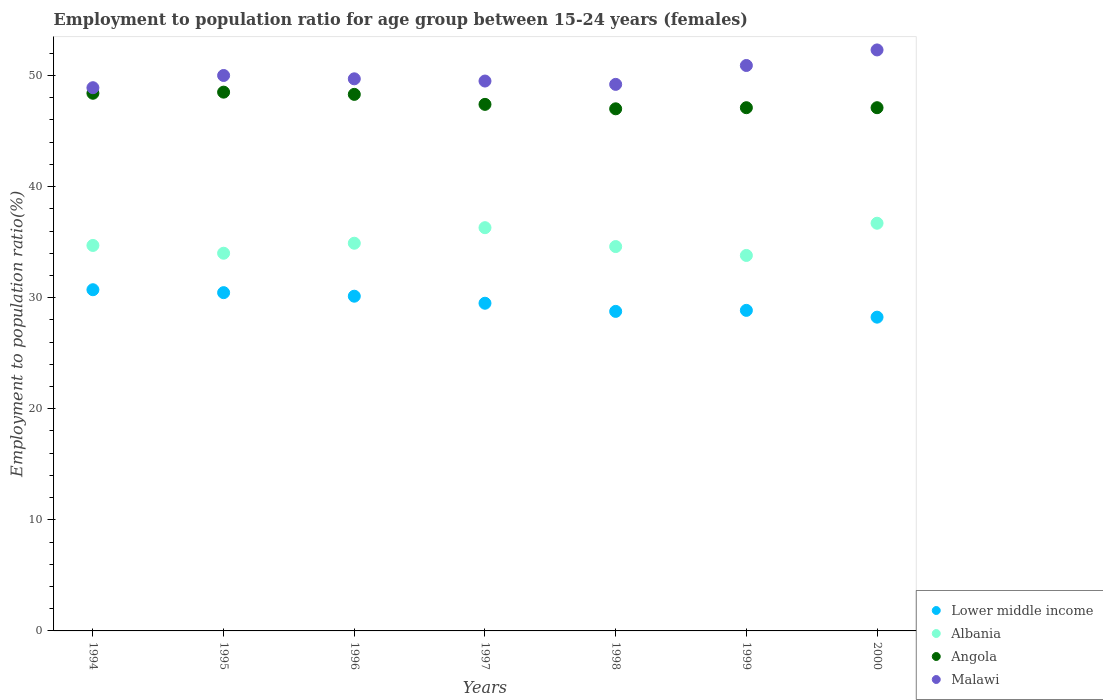Is the number of dotlines equal to the number of legend labels?
Keep it short and to the point. Yes. What is the employment to population ratio in Lower middle income in 1998?
Your answer should be compact. 28.76. Across all years, what is the maximum employment to population ratio in Malawi?
Your response must be concise. 52.3. Across all years, what is the minimum employment to population ratio in Albania?
Make the answer very short. 33.8. In which year was the employment to population ratio in Lower middle income maximum?
Your response must be concise. 1994. What is the total employment to population ratio in Angola in the graph?
Your answer should be very brief. 333.8. What is the difference between the employment to population ratio in Lower middle income in 1997 and that in 2000?
Give a very brief answer. 1.25. What is the difference between the employment to population ratio in Lower middle income in 1994 and the employment to population ratio in Angola in 1999?
Keep it short and to the point. -16.39. What is the average employment to population ratio in Lower middle income per year?
Your answer should be compact. 29.52. What is the ratio of the employment to population ratio in Malawi in 1994 to that in 1997?
Your answer should be compact. 0.99. Is the employment to population ratio in Angola in 1997 less than that in 1998?
Ensure brevity in your answer.  No. Is the difference between the employment to population ratio in Albania in 1995 and 1997 greater than the difference between the employment to population ratio in Angola in 1995 and 1997?
Offer a very short reply. No. What is the difference between the highest and the second highest employment to population ratio in Lower middle income?
Offer a very short reply. 0.26. In how many years, is the employment to population ratio in Malawi greater than the average employment to population ratio in Malawi taken over all years?
Your answer should be very brief. 2. What is the difference between two consecutive major ticks on the Y-axis?
Ensure brevity in your answer.  10. Does the graph contain any zero values?
Keep it short and to the point. No. Does the graph contain grids?
Offer a very short reply. No. Where does the legend appear in the graph?
Make the answer very short. Bottom right. How many legend labels are there?
Make the answer very short. 4. What is the title of the graph?
Give a very brief answer. Employment to population ratio for age group between 15-24 years (females). What is the label or title of the X-axis?
Your response must be concise. Years. What is the label or title of the Y-axis?
Give a very brief answer. Employment to population ratio(%). What is the Employment to population ratio(%) in Lower middle income in 1994?
Your response must be concise. 30.71. What is the Employment to population ratio(%) in Albania in 1994?
Give a very brief answer. 34.7. What is the Employment to population ratio(%) in Angola in 1994?
Your response must be concise. 48.4. What is the Employment to population ratio(%) of Malawi in 1994?
Provide a succinct answer. 48.9. What is the Employment to population ratio(%) in Lower middle income in 1995?
Offer a very short reply. 30.45. What is the Employment to population ratio(%) in Angola in 1995?
Keep it short and to the point. 48.5. What is the Employment to population ratio(%) in Lower middle income in 1996?
Keep it short and to the point. 30.13. What is the Employment to population ratio(%) in Albania in 1996?
Give a very brief answer. 34.9. What is the Employment to population ratio(%) of Angola in 1996?
Offer a terse response. 48.3. What is the Employment to population ratio(%) of Malawi in 1996?
Your response must be concise. 49.7. What is the Employment to population ratio(%) of Lower middle income in 1997?
Offer a terse response. 29.5. What is the Employment to population ratio(%) of Albania in 1997?
Keep it short and to the point. 36.3. What is the Employment to population ratio(%) in Angola in 1997?
Your answer should be very brief. 47.4. What is the Employment to population ratio(%) in Malawi in 1997?
Ensure brevity in your answer.  49.5. What is the Employment to population ratio(%) of Lower middle income in 1998?
Offer a very short reply. 28.76. What is the Employment to population ratio(%) of Albania in 1998?
Ensure brevity in your answer.  34.6. What is the Employment to population ratio(%) in Angola in 1998?
Offer a terse response. 47. What is the Employment to population ratio(%) in Malawi in 1998?
Your answer should be very brief. 49.2. What is the Employment to population ratio(%) of Lower middle income in 1999?
Your answer should be compact. 28.86. What is the Employment to population ratio(%) in Albania in 1999?
Provide a succinct answer. 33.8. What is the Employment to population ratio(%) of Angola in 1999?
Give a very brief answer. 47.1. What is the Employment to population ratio(%) in Malawi in 1999?
Your answer should be compact. 50.9. What is the Employment to population ratio(%) in Lower middle income in 2000?
Keep it short and to the point. 28.24. What is the Employment to population ratio(%) of Albania in 2000?
Make the answer very short. 36.7. What is the Employment to population ratio(%) of Angola in 2000?
Your answer should be compact. 47.1. What is the Employment to population ratio(%) of Malawi in 2000?
Make the answer very short. 52.3. Across all years, what is the maximum Employment to population ratio(%) of Lower middle income?
Your answer should be compact. 30.71. Across all years, what is the maximum Employment to population ratio(%) of Albania?
Offer a terse response. 36.7. Across all years, what is the maximum Employment to population ratio(%) of Angola?
Your answer should be very brief. 48.5. Across all years, what is the maximum Employment to population ratio(%) in Malawi?
Offer a very short reply. 52.3. Across all years, what is the minimum Employment to population ratio(%) of Lower middle income?
Give a very brief answer. 28.24. Across all years, what is the minimum Employment to population ratio(%) in Albania?
Offer a terse response. 33.8. Across all years, what is the minimum Employment to population ratio(%) in Malawi?
Provide a short and direct response. 48.9. What is the total Employment to population ratio(%) in Lower middle income in the graph?
Ensure brevity in your answer.  206.66. What is the total Employment to population ratio(%) in Albania in the graph?
Make the answer very short. 245. What is the total Employment to population ratio(%) in Angola in the graph?
Offer a terse response. 333.8. What is the total Employment to population ratio(%) of Malawi in the graph?
Keep it short and to the point. 350.5. What is the difference between the Employment to population ratio(%) in Lower middle income in 1994 and that in 1995?
Make the answer very short. 0.26. What is the difference between the Employment to population ratio(%) in Albania in 1994 and that in 1995?
Offer a very short reply. 0.7. What is the difference between the Employment to population ratio(%) of Angola in 1994 and that in 1995?
Your response must be concise. -0.1. What is the difference between the Employment to population ratio(%) in Lower middle income in 1994 and that in 1996?
Make the answer very short. 0.58. What is the difference between the Employment to population ratio(%) in Lower middle income in 1994 and that in 1997?
Your response must be concise. 1.22. What is the difference between the Employment to population ratio(%) in Lower middle income in 1994 and that in 1998?
Your answer should be compact. 1.95. What is the difference between the Employment to population ratio(%) in Malawi in 1994 and that in 1998?
Keep it short and to the point. -0.3. What is the difference between the Employment to population ratio(%) in Lower middle income in 1994 and that in 1999?
Ensure brevity in your answer.  1.86. What is the difference between the Employment to population ratio(%) of Angola in 1994 and that in 1999?
Offer a terse response. 1.3. What is the difference between the Employment to population ratio(%) in Lower middle income in 1994 and that in 2000?
Offer a very short reply. 2.47. What is the difference between the Employment to population ratio(%) in Albania in 1994 and that in 2000?
Ensure brevity in your answer.  -2. What is the difference between the Employment to population ratio(%) in Malawi in 1994 and that in 2000?
Ensure brevity in your answer.  -3.4. What is the difference between the Employment to population ratio(%) in Lower middle income in 1995 and that in 1996?
Offer a very short reply. 0.32. What is the difference between the Employment to population ratio(%) in Albania in 1995 and that in 1996?
Offer a very short reply. -0.9. What is the difference between the Employment to population ratio(%) in Angola in 1995 and that in 1996?
Give a very brief answer. 0.2. What is the difference between the Employment to population ratio(%) of Malawi in 1995 and that in 1996?
Offer a very short reply. 0.3. What is the difference between the Employment to population ratio(%) of Lower middle income in 1995 and that in 1997?
Provide a succinct answer. 0.95. What is the difference between the Employment to population ratio(%) of Lower middle income in 1995 and that in 1998?
Your response must be concise. 1.69. What is the difference between the Employment to population ratio(%) of Malawi in 1995 and that in 1998?
Provide a succinct answer. 0.8. What is the difference between the Employment to population ratio(%) in Lower middle income in 1995 and that in 1999?
Offer a terse response. 1.59. What is the difference between the Employment to population ratio(%) in Albania in 1995 and that in 1999?
Provide a short and direct response. 0.2. What is the difference between the Employment to population ratio(%) in Lower middle income in 1995 and that in 2000?
Provide a short and direct response. 2.21. What is the difference between the Employment to population ratio(%) in Lower middle income in 1996 and that in 1997?
Your answer should be compact. 0.63. What is the difference between the Employment to population ratio(%) in Malawi in 1996 and that in 1997?
Make the answer very short. 0.2. What is the difference between the Employment to population ratio(%) in Lower middle income in 1996 and that in 1998?
Your response must be concise. 1.37. What is the difference between the Employment to population ratio(%) in Albania in 1996 and that in 1998?
Offer a very short reply. 0.3. What is the difference between the Employment to population ratio(%) in Lower middle income in 1996 and that in 1999?
Give a very brief answer. 1.27. What is the difference between the Employment to population ratio(%) in Angola in 1996 and that in 1999?
Give a very brief answer. 1.2. What is the difference between the Employment to population ratio(%) in Malawi in 1996 and that in 1999?
Provide a short and direct response. -1.2. What is the difference between the Employment to population ratio(%) in Lower middle income in 1996 and that in 2000?
Give a very brief answer. 1.89. What is the difference between the Employment to population ratio(%) in Angola in 1996 and that in 2000?
Offer a terse response. 1.2. What is the difference between the Employment to population ratio(%) in Lower middle income in 1997 and that in 1998?
Your answer should be compact. 0.73. What is the difference between the Employment to population ratio(%) of Albania in 1997 and that in 1998?
Your answer should be very brief. 1.7. What is the difference between the Employment to population ratio(%) in Malawi in 1997 and that in 1998?
Ensure brevity in your answer.  0.3. What is the difference between the Employment to population ratio(%) in Lower middle income in 1997 and that in 1999?
Give a very brief answer. 0.64. What is the difference between the Employment to population ratio(%) of Albania in 1997 and that in 1999?
Ensure brevity in your answer.  2.5. What is the difference between the Employment to population ratio(%) of Malawi in 1997 and that in 1999?
Your response must be concise. -1.4. What is the difference between the Employment to population ratio(%) of Lower middle income in 1997 and that in 2000?
Make the answer very short. 1.25. What is the difference between the Employment to population ratio(%) of Albania in 1997 and that in 2000?
Give a very brief answer. -0.4. What is the difference between the Employment to population ratio(%) in Lower middle income in 1998 and that in 1999?
Provide a short and direct response. -0.09. What is the difference between the Employment to population ratio(%) of Angola in 1998 and that in 1999?
Offer a terse response. -0.1. What is the difference between the Employment to population ratio(%) of Lower middle income in 1998 and that in 2000?
Provide a short and direct response. 0.52. What is the difference between the Employment to population ratio(%) of Albania in 1998 and that in 2000?
Ensure brevity in your answer.  -2.1. What is the difference between the Employment to population ratio(%) of Angola in 1998 and that in 2000?
Provide a succinct answer. -0.1. What is the difference between the Employment to population ratio(%) of Malawi in 1998 and that in 2000?
Offer a very short reply. -3.1. What is the difference between the Employment to population ratio(%) in Lower middle income in 1999 and that in 2000?
Give a very brief answer. 0.61. What is the difference between the Employment to population ratio(%) of Albania in 1999 and that in 2000?
Offer a terse response. -2.9. What is the difference between the Employment to population ratio(%) in Angola in 1999 and that in 2000?
Your answer should be very brief. 0. What is the difference between the Employment to population ratio(%) in Malawi in 1999 and that in 2000?
Your response must be concise. -1.4. What is the difference between the Employment to population ratio(%) in Lower middle income in 1994 and the Employment to population ratio(%) in Albania in 1995?
Offer a terse response. -3.29. What is the difference between the Employment to population ratio(%) in Lower middle income in 1994 and the Employment to population ratio(%) in Angola in 1995?
Ensure brevity in your answer.  -17.79. What is the difference between the Employment to population ratio(%) of Lower middle income in 1994 and the Employment to population ratio(%) of Malawi in 1995?
Give a very brief answer. -19.29. What is the difference between the Employment to population ratio(%) in Albania in 1994 and the Employment to population ratio(%) in Malawi in 1995?
Give a very brief answer. -15.3. What is the difference between the Employment to population ratio(%) in Angola in 1994 and the Employment to population ratio(%) in Malawi in 1995?
Offer a very short reply. -1.6. What is the difference between the Employment to population ratio(%) in Lower middle income in 1994 and the Employment to population ratio(%) in Albania in 1996?
Provide a short and direct response. -4.19. What is the difference between the Employment to population ratio(%) in Lower middle income in 1994 and the Employment to population ratio(%) in Angola in 1996?
Make the answer very short. -17.59. What is the difference between the Employment to population ratio(%) in Lower middle income in 1994 and the Employment to population ratio(%) in Malawi in 1996?
Keep it short and to the point. -18.99. What is the difference between the Employment to population ratio(%) in Albania in 1994 and the Employment to population ratio(%) in Malawi in 1996?
Your answer should be very brief. -15. What is the difference between the Employment to population ratio(%) in Angola in 1994 and the Employment to population ratio(%) in Malawi in 1996?
Your response must be concise. -1.3. What is the difference between the Employment to population ratio(%) in Lower middle income in 1994 and the Employment to population ratio(%) in Albania in 1997?
Offer a very short reply. -5.59. What is the difference between the Employment to population ratio(%) of Lower middle income in 1994 and the Employment to population ratio(%) of Angola in 1997?
Keep it short and to the point. -16.69. What is the difference between the Employment to population ratio(%) of Lower middle income in 1994 and the Employment to population ratio(%) of Malawi in 1997?
Give a very brief answer. -18.79. What is the difference between the Employment to population ratio(%) in Albania in 1994 and the Employment to population ratio(%) in Angola in 1997?
Make the answer very short. -12.7. What is the difference between the Employment to population ratio(%) of Albania in 1994 and the Employment to population ratio(%) of Malawi in 1997?
Provide a succinct answer. -14.8. What is the difference between the Employment to population ratio(%) in Lower middle income in 1994 and the Employment to population ratio(%) in Albania in 1998?
Your answer should be very brief. -3.89. What is the difference between the Employment to population ratio(%) of Lower middle income in 1994 and the Employment to population ratio(%) of Angola in 1998?
Your answer should be compact. -16.29. What is the difference between the Employment to population ratio(%) in Lower middle income in 1994 and the Employment to population ratio(%) in Malawi in 1998?
Your answer should be very brief. -18.49. What is the difference between the Employment to population ratio(%) of Albania in 1994 and the Employment to population ratio(%) of Malawi in 1998?
Give a very brief answer. -14.5. What is the difference between the Employment to population ratio(%) of Lower middle income in 1994 and the Employment to population ratio(%) of Albania in 1999?
Your response must be concise. -3.09. What is the difference between the Employment to population ratio(%) of Lower middle income in 1994 and the Employment to population ratio(%) of Angola in 1999?
Provide a short and direct response. -16.39. What is the difference between the Employment to population ratio(%) in Lower middle income in 1994 and the Employment to population ratio(%) in Malawi in 1999?
Your answer should be very brief. -20.19. What is the difference between the Employment to population ratio(%) of Albania in 1994 and the Employment to population ratio(%) of Malawi in 1999?
Your answer should be very brief. -16.2. What is the difference between the Employment to population ratio(%) of Lower middle income in 1994 and the Employment to population ratio(%) of Albania in 2000?
Give a very brief answer. -5.99. What is the difference between the Employment to population ratio(%) of Lower middle income in 1994 and the Employment to population ratio(%) of Angola in 2000?
Your answer should be very brief. -16.39. What is the difference between the Employment to population ratio(%) in Lower middle income in 1994 and the Employment to population ratio(%) in Malawi in 2000?
Offer a terse response. -21.59. What is the difference between the Employment to population ratio(%) of Albania in 1994 and the Employment to population ratio(%) of Malawi in 2000?
Make the answer very short. -17.6. What is the difference between the Employment to population ratio(%) in Lower middle income in 1995 and the Employment to population ratio(%) in Albania in 1996?
Make the answer very short. -4.45. What is the difference between the Employment to population ratio(%) of Lower middle income in 1995 and the Employment to population ratio(%) of Angola in 1996?
Offer a very short reply. -17.85. What is the difference between the Employment to population ratio(%) of Lower middle income in 1995 and the Employment to population ratio(%) of Malawi in 1996?
Your answer should be compact. -19.25. What is the difference between the Employment to population ratio(%) of Albania in 1995 and the Employment to population ratio(%) of Angola in 1996?
Offer a very short reply. -14.3. What is the difference between the Employment to population ratio(%) of Albania in 1995 and the Employment to population ratio(%) of Malawi in 1996?
Make the answer very short. -15.7. What is the difference between the Employment to population ratio(%) in Lower middle income in 1995 and the Employment to population ratio(%) in Albania in 1997?
Your response must be concise. -5.85. What is the difference between the Employment to population ratio(%) in Lower middle income in 1995 and the Employment to population ratio(%) in Angola in 1997?
Provide a succinct answer. -16.95. What is the difference between the Employment to population ratio(%) of Lower middle income in 1995 and the Employment to population ratio(%) of Malawi in 1997?
Provide a succinct answer. -19.05. What is the difference between the Employment to population ratio(%) in Albania in 1995 and the Employment to population ratio(%) in Angola in 1997?
Make the answer very short. -13.4. What is the difference between the Employment to population ratio(%) in Albania in 1995 and the Employment to population ratio(%) in Malawi in 1997?
Offer a very short reply. -15.5. What is the difference between the Employment to population ratio(%) in Angola in 1995 and the Employment to population ratio(%) in Malawi in 1997?
Make the answer very short. -1. What is the difference between the Employment to population ratio(%) of Lower middle income in 1995 and the Employment to population ratio(%) of Albania in 1998?
Provide a short and direct response. -4.15. What is the difference between the Employment to population ratio(%) of Lower middle income in 1995 and the Employment to population ratio(%) of Angola in 1998?
Offer a very short reply. -16.55. What is the difference between the Employment to population ratio(%) in Lower middle income in 1995 and the Employment to population ratio(%) in Malawi in 1998?
Make the answer very short. -18.75. What is the difference between the Employment to population ratio(%) in Albania in 1995 and the Employment to population ratio(%) in Angola in 1998?
Your answer should be compact. -13. What is the difference between the Employment to population ratio(%) of Albania in 1995 and the Employment to population ratio(%) of Malawi in 1998?
Your response must be concise. -15.2. What is the difference between the Employment to population ratio(%) in Angola in 1995 and the Employment to population ratio(%) in Malawi in 1998?
Your answer should be compact. -0.7. What is the difference between the Employment to population ratio(%) of Lower middle income in 1995 and the Employment to population ratio(%) of Albania in 1999?
Your answer should be very brief. -3.35. What is the difference between the Employment to population ratio(%) in Lower middle income in 1995 and the Employment to population ratio(%) in Angola in 1999?
Make the answer very short. -16.65. What is the difference between the Employment to population ratio(%) in Lower middle income in 1995 and the Employment to population ratio(%) in Malawi in 1999?
Your answer should be compact. -20.45. What is the difference between the Employment to population ratio(%) in Albania in 1995 and the Employment to population ratio(%) in Malawi in 1999?
Ensure brevity in your answer.  -16.9. What is the difference between the Employment to population ratio(%) of Lower middle income in 1995 and the Employment to population ratio(%) of Albania in 2000?
Keep it short and to the point. -6.25. What is the difference between the Employment to population ratio(%) in Lower middle income in 1995 and the Employment to population ratio(%) in Angola in 2000?
Give a very brief answer. -16.65. What is the difference between the Employment to population ratio(%) in Lower middle income in 1995 and the Employment to population ratio(%) in Malawi in 2000?
Keep it short and to the point. -21.85. What is the difference between the Employment to population ratio(%) in Albania in 1995 and the Employment to population ratio(%) in Malawi in 2000?
Your answer should be very brief. -18.3. What is the difference between the Employment to population ratio(%) of Angola in 1995 and the Employment to population ratio(%) of Malawi in 2000?
Your answer should be compact. -3.8. What is the difference between the Employment to population ratio(%) of Lower middle income in 1996 and the Employment to population ratio(%) of Albania in 1997?
Offer a terse response. -6.17. What is the difference between the Employment to population ratio(%) in Lower middle income in 1996 and the Employment to population ratio(%) in Angola in 1997?
Provide a succinct answer. -17.27. What is the difference between the Employment to population ratio(%) in Lower middle income in 1996 and the Employment to population ratio(%) in Malawi in 1997?
Give a very brief answer. -19.37. What is the difference between the Employment to population ratio(%) of Albania in 1996 and the Employment to population ratio(%) of Malawi in 1997?
Provide a succinct answer. -14.6. What is the difference between the Employment to population ratio(%) of Lower middle income in 1996 and the Employment to population ratio(%) of Albania in 1998?
Keep it short and to the point. -4.47. What is the difference between the Employment to population ratio(%) of Lower middle income in 1996 and the Employment to population ratio(%) of Angola in 1998?
Your answer should be very brief. -16.87. What is the difference between the Employment to population ratio(%) in Lower middle income in 1996 and the Employment to population ratio(%) in Malawi in 1998?
Provide a short and direct response. -19.07. What is the difference between the Employment to population ratio(%) of Albania in 1996 and the Employment to population ratio(%) of Malawi in 1998?
Your answer should be very brief. -14.3. What is the difference between the Employment to population ratio(%) in Lower middle income in 1996 and the Employment to population ratio(%) in Albania in 1999?
Your answer should be very brief. -3.67. What is the difference between the Employment to population ratio(%) of Lower middle income in 1996 and the Employment to population ratio(%) of Angola in 1999?
Make the answer very short. -16.97. What is the difference between the Employment to population ratio(%) in Lower middle income in 1996 and the Employment to population ratio(%) in Malawi in 1999?
Give a very brief answer. -20.77. What is the difference between the Employment to population ratio(%) of Albania in 1996 and the Employment to population ratio(%) of Angola in 1999?
Provide a succinct answer. -12.2. What is the difference between the Employment to population ratio(%) in Angola in 1996 and the Employment to population ratio(%) in Malawi in 1999?
Your answer should be very brief. -2.6. What is the difference between the Employment to population ratio(%) of Lower middle income in 1996 and the Employment to population ratio(%) of Albania in 2000?
Provide a short and direct response. -6.57. What is the difference between the Employment to population ratio(%) of Lower middle income in 1996 and the Employment to population ratio(%) of Angola in 2000?
Provide a succinct answer. -16.97. What is the difference between the Employment to population ratio(%) of Lower middle income in 1996 and the Employment to population ratio(%) of Malawi in 2000?
Give a very brief answer. -22.17. What is the difference between the Employment to population ratio(%) in Albania in 1996 and the Employment to population ratio(%) in Malawi in 2000?
Your answer should be compact. -17.4. What is the difference between the Employment to population ratio(%) in Angola in 1996 and the Employment to population ratio(%) in Malawi in 2000?
Offer a very short reply. -4. What is the difference between the Employment to population ratio(%) in Lower middle income in 1997 and the Employment to population ratio(%) in Albania in 1998?
Keep it short and to the point. -5.1. What is the difference between the Employment to population ratio(%) of Lower middle income in 1997 and the Employment to population ratio(%) of Angola in 1998?
Provide a succinct answer. -17.5. What is the difference between the Employment to population ratio(%) of Lower middle income in 1997 and the Employment to population ratio(%) of Malawi in 1998?
Provide a succinct answer. -19.7. What is the difference between the Employment to population ratio(%) in Albania in 1997 and the Employment to population ratio(%) in Angola in 1998?
Give a very brief answer. -10.7. What is the difference between the Employment to population ratio(%) of Albania in 1997 and the Employment to population ratio(%) of Malawi in 1998?
Your answer should be compact. -12.9. What is the difference between the Employment to population ratio(%) in Angola in 1997 and the Employment to population ratio(%) in Malawi in 1998?
Offer a terse response. -1.8. What is the difference between the Employment to population ratio(%) in Lower middle income in 1997 and the Employment to population ratio(%) in Albania in 1999?
Your response must be concise. -4.3. What is the difference between the Employment to population ratio(%) of Lower middle income in 1997 and the Employment to population ratio(%) of Angola in 1999?
Provide a short and direct response. -17.6. What is the difference between the Employment to population ratio(%) in Lower middle income in 1997 and the Employment to population ratio(%) in Malawi in 1999?
Keep it short and to the point. -21.4. What is the difference between the Employment to population ratio(%) of Albania in 1997 and the Employment to population ratio(%) of Malawi in 1999?
Offer a very short reply. -14.6. What is the difference between the Employment to population ratio(%) in Angola in 1997 and the Employment to population ratio(%) in Malawi in 1999?
Your response must be concise. -3.5. What is the difference between the Employment to population ratio(%) in Lower middle income in 1997 and the Employment to population ratio(%) in Albania in 2000?
Give a very brief answer. -7.2. What is the difference between the Employment to population ratio(%) of Lower middle income in 1997 and the Employment to population ratio(%) of Angola in 2000?
Keep it short and to the point. -17.6. What is the difference between the Employment to population ratio(%) in Lower middle income in 1997 and the Employment to population ratio(%) in Malawi in 2000?
Make the answer very short. -22.8. What is the difference between the Employment to population ratio(%) of Albania in 1997 and the Employment to population ratio(%) of Angola in 2000?
Provide a short and direct response. -10.8. What is the difference between the Employment to population ratio(%) in Lower middle income in 1998 and the Employment to population ratio(%) in Albania in 1999?
Provide a short and direct response. -5.04. What is the difference between the Employment to population ratio(%) of Lower middle income in 1998 and the Employment to population ratio(%) of Angola in 1999?
Keep it short and to the point. -18.34. What is the difference between the Employment to population ratio(%) of Lower middle income in 1998 and the Employment to population ratio(%) of Malawi in 1999?
Your answer should be compact. -22.14. What is the difference between the Employment to population ratio(%) in Albania in 1998 and the Employment to population ratio(%) in Malawi in 1999?
Give a very brief answer. -16.3. What is the difference between the Employment to population ratio(%) in Lower middle income in 1998 and the Employment to population ratio(%) in Albania in 2000?
Offer a terse response. -7.94. What is the difference between the Employment to population ratio(%) of Lower middle income in 1998 and the Employment to population ratio(%) of Angola in 2000?
Your answer should be compact. -18.34. What is the difference between the Employment to population ratio(%) in Lower middle income in 1998 and the Employment to population ratio(%) in Malawi in 2000?
Ensure brevity in your answer.  -23.54. What is the difference between the Employment to population ratio(%) of Albania in 1998 and the Employment to population ratio(%) of Malawi in 2000?
Your answer should be very brief. -17.7. What is the difference between the Employment to population ratio(%) in Angola in 1998 and the Employment to population ratio(%) in Malawi in 2000?
Offer a terse response. -5.3. What is the difference between the Employment to population ratio(%) in Lower middle income in 1999 and the Employment to population ratio(%) in Albania in 2000?
Provide a succinct answer. -7.84. What is the difference between the Employment to population ratio(%) in Lower middle income in 1999 and the Employment to population ratio(%) in Angola in 2000?
Offer a very short reply. -18.24. What is the difference between the Employment to population ratio(%) in Lower middle income in 1999 and the Employment to population ratio(%) in Malawi in 2000?
Provide a succinct answer. -23.44. What is the difference between the Employment to population ratio(%) of Albania in 1999 and the Employment to population ratio(%) of Angola in 2000?
Give a very brief answer. -13.3. What is the difference between the Employment to population ratio(%) in Albania in 1999 and the Employment to population ratio(%) in Malawi in 2000?
Give a very brief answer. -18.5. What is the difference between the Employment to population ratio(%) of Angola in 1999 and the Employment to population ratio(%) of Malawi in 2000?
Your response must be concise. -5.2. What is the average Employment to population ratio(%) of Lower middle income per year?
Offer a terse response. 29.52. What is the average Employment to population ratio(%) in Albania per year?
Give a very brief answer. 35. What is the average Employment to population ratio(%) of Angola per year?
Ensure brevity in your answer.  47.69. What is the average Employment to population ratio(%) of Malawi per year?
Your response must be concise. 50.07. In the year 1994, what is the difference between the Employment to population ratio(%) of Lower middle income and Employment to population ratio(%) of Albania?
Offer a very short reply. -3.99. In the year 1994, what is the difference between the Employment to population ratio(%) in Lower middle income and Employment to population ratio(%) in Angola?
Provide a short and direct response. -17.69. In the year 1994, what is the difference between the Employment to population ratio(%) of Lower middle income and Employment to population ratio(%) of Malawi?
Keep it short and to the point. -18.19. In the year 1994, what is the difference between the Employment to population ratio(%) of Albania and Employment to population ratio(%) of Angola?
Your answer should be very brief. -13.7. In the year 1994, what is the difference between the Employment to population ratio(%) of Angola and Employment to population ratio(%) of Malawi?
Keep it short and to the point. -0.5. In the year 1995, what is the difference between the Employment to population ratio(%) in Lower middle income and Employment to population ratio(%) in Albania?
Ensure brevity in your answer.  -3.55. In the year 1995, what is the difference between the Employment to population ratio(%) of Lower middle income and Employment to population ratio(%) of Angola?
Give a very brief answer. -18.05. In the year 1995, what is the difference between the Employment to population ratio(%) of Lower middle income and Employment to population ratio(%) of Malawi?
Give a very brief answer. -19.55. In the year 1996, what is the difference between the Employment to population ratio(%) of Lower middle income and Employment to population ratio(%) of Albania?
Provide a short and direct response. -4.77. In the year 1996, what is the difference between the Employment to population ratio(%) of Lower middle income and Employment to population ratio(%) of Angola?
Keep it short and to the point. -18.17. In the year 1996, what is the difference between the Employment to population ratio(%) in Lower middle income and Employment to population ratio(%) in Malawi?
Provide a succinct answer. -19.57. In the year 1996, what is the difference between the Employment to population ratio(%) in Albania and Employment to population ratio(%) in Malawi?
Make the answer very short. -14.8. In the year 1996, what is the difference between the Employment to population ratio(%) in Angola and Employment to population ratio(%) in Malawi?
Keep it short and to the point. -1.4. In the year 1997, what is the difference between the Employment to population ratio(%) in Lower middle income and Employment to population ratio(%) in Albania?
Offer a terse response. -6.8. In the year 1997, what is the difference between the Employment to population ratio(%) of Lower middle income and Employment to population ratio(%) of Angola?
Give a very brief answer. -17.9. In the year 1997, what is the difference between the Employment to population ratio(%) in Lower middle income and Employment to population ratio(%) in Malawi?
Keep it short and to the point. -20. In the year 1998, what is the difference between the Employment to population ratio(%) of Lower middle income and Employment to population ratio(%) of Albania?
Ensure brevity in your answer.  -5.84. In the year 1998, what is the difference between the Employment to population ratio(%) in Lower middle income and Employment to population ratio(%) in Angola?
Provide a succinct answer. -18.24. In the year 1998, what is the difference between the Employment to population ratio(%) of Lower middle income and Employment to population ratio(%) of Malawi?
Provide a succinct answer. -20.44. In the year 1998, what is the difference between the Employment to population ratio(%) in Albania and Employment to population ratio(%) in Malawi?
Offer a very short reply. -14.6. In the year 1998, what is the difference between the Employment to population ratio(%) in Angola and Employment to population ratio(%) in Malawi?
Provide a succinct answer. -2.2. In the year 1999, what is the difference between the Employment to population ratio(%) of Lower middle income and Employment to population ratio(%) of Albania?
Your answer should be compact. -4.94. In the year 1999, what is the difference between the Employment to population ratio(%) of Lower middle income and Employment to population ratio(%) of Angola?
Make the answer very short. -18.24. In the year 1999, what is the difference between the Employment to population ratio(%) in Lower middle income and Employment to population ratio(%) in Malawi?
Offer a very short reply. -22.04. In the year 1999, what is the difference between the Employment to population ratio(%) in Albania and Employment to population ratio(%) in Angola?
Give a very brief answer. -13.3. In the year 1999, what is the difference between the Employment to population ratio(%) of Albania and Employment to population ratio(%) of Malawi?
Provide a short and direct response. -17.1. In the year 1999, what is the difference between the Employment to population ratio(%) in Angola and Employment to population ratio(%) in Malawi?
Your answer should be compact. -3.8. In the year 2000, what is the difference between the Employment to population ratio(%) of Lower middle income and Employment to population ratio(%) of Albania?
Keep it short and to the point. -8.46. In the year 2000, what is the difference between the Employment to population ratio(%) of Lower middle income and Employment to population ratio(%) of Angola?
Your answer should be compact. -18.86. In the year 2000, what is the difference between the Employment to population ratio(%) in Lower middle income and Employment to population ratio(%) in Malawi?
Your response must be concise. -24.06. In the year 2000, what is the difference between the Employment to population ratio(%) of Albania and Employment to population ratio(%) of Malawi?
Your answer should be very brief. -15.6. What is the ratio of the Employment to population ratio(%) in Lower middle income in 1994 to that in 1995?
Your answer should be compact. 1.01. What is the ratio of the Employment to population ratio(%) of Albania in 1994 to that in 1995?
Provide a short and direct response. 1.02. What is the ratio of the Employment to population ratio(%) in Malawi in 1994 to that in 1995?
Ensure brevity in your answer.  0.98. What is the ratio of the Employment to population ratio(%) in Lower middle income in 1994 to that in 1996?
Your response must be concise. 1.02. What is the ratio of the Employment to population ratio(%) in Angola in 1994 to that in 1996?
Make the answer very short. 1. What is the ratio of the Employment to population ratio(%) of Malawi in 1994 to that in 1996?
Offer a very short reply. 0.98. What is the ratio of the Employment to population ratio(%) in Lower middle income in 1994 to that in 1997?
Provide a succinct answer. 1.04. What is the ratio of the Employment to population ratio(%) of Albania in 1994 to that in 1997?
Offer a terse response. 0.96. What is the ratio of the Employment to population ratio(%) of Angola in 1994 to that in 1997?
Keep it short and to the point. 1.02. What is the ratio of the Employment to population ratio(%) in Malawi in 1994 to that in 1997?
Offer a very short reply. 0.99. What is the ratio of the Employment to population ratio(%) of Lower middle income in 1994 to that in 1998?
Your answer should be very brief. 1.07. What is the ratio of the Employment to population ratio(%) in Albania in 1994 to that in 1998?
Provide a short and direct response. 1. What is the ratio of the Employment to population ratio(%) of Angola in 1994 to that in 1998?
Provide a succinct answer. 1.03. What is the ratio of the Employment to population ratio(%) in Malawi in 1994 to that in 1998?
Provide a short and direct response. 0.99. What is the ratio of the Employment to population ratio(%) of Lower middle income in 1994 to that in 1999?
Offer a very short reply. 1.06. What is the ratio of the Employment to population ratio(%) in Albania in 1994 to that in 1999?
Make the answer very short. 1.03. What is the ratio of the Employment to population ratio(%) in Angola in 1994 to that in 1999?
Provide a short and direct response. 1.03. What is the ratio of the Employment to population ratio(%) in Malawi in 1994 to that in 1999?
Provide a short and direct response. 0.96. What is the ratio of the Employment to population ratio(%) of Lower middle income in 1994 to that in 2000?
Your answer should be compact. 1.09. What is the ratio of the Employment to population ratio(%) of Albania in 1994 to that in 2000?
Provide a succinct answer. 0.95. What is the ratio of the Employment to population ratio(%) in Angola in 1994 to that in 2000?
Offer a very short reply. 1.03. What is the ratio of the Employment to population ratio(%) of Malawi in 1994 to that in 2000?
Your answer should be very brief. 0.94. What is the ratio of the Employment to population ratio(%) in Lower middle income in 1995 to that in 1996?
Your answer should be compact. 1.01. What is the ratio of the Employment to population ratio(%) in Albania in 1995 to that in 1996?
Offer a very short reply. 0.97. What is the ratio of the Employment to population ratio(%) in Angola in 1995 to that in 1996?
Ensure brevity in your answer.  1. What is the ratio of the Employment to population ratio(%) in Lower middle income in 1995 to that in 1997?
Provide a short and direct response. 1.03. What is the ratio of the Employment to population ratio(%) in Albania in 1995 to that in 1997?
Provide a short and direct response. 0.94. What is the ratio of the Employment to population ratio(%) in Angola in 1995 to that in 1997?
Give a very brief answer. 1.02. What is the ratio of the Employment to population ratio(%) in Malawi in 1995 to that in 1997?
Keep it short and to the point. 1.01. What is the ratio of the Employment to population ratio(%) in Lower middle income in 1995 to that in 1998?
Your answer should be compact. 1.06. What is the ratio of the Employment to population ratio(%) of Albania in 1995 to that in 1998?
Provide a succinct answer. 0.98. What is the ratio of the Employment to population ratio(%) in Angola in 1995 to that in 1998?
Your response must be concise. 1.03. What is the ratio of the Employment to population ratio(%) in Malawi in 1995 to that in 1998?
Offer a terse response. 1.02. What is the ratio of the Employment to population ratio(%) in Lower middle income in 1995 to that in 1999?
Provide a short and direct response. 1.06. What is the ratio of the Employment to population ratio(%) in Albania in 1995 to that in 1999?
Provide a short and direct response. 1.01. What is the ratio of the Employment to population ratio(%) in Angola in 1995 to that in 1999?
Offer a terse response. 1.03. What is the ratio of the Employment to population ratio(%) of Malawi in 1995 to that in 1999?
Provide a short and direct response. 0.98. What is the ratio of the Employment to population ratio(%) of Lower middle income in 1995 to that in 2000?
Keep it short and to the point. 1.08. What is the ratio of the Employment to population ratio(%) in Albania in 1995 to that in 2000?
Provide a succinct answer. 0.93. What is the ratio of the Employment to population ratio(%) in Angola in 1995 to that in 2000?
Provide a succinct answer. 1.03. What is the ratio of the Employment to population ratio(%) of Malawi in 1995 to that in 2000?
Your response must be concise. 0.96. What is the ratio of the Employment to population ratio(%) in Lower middle income in 1996 to that in 1997?
Provide a succinct answer. 1.02. What is the ratio of the Employment to population ratio(%) of Albania in 1996 to that in 1997?
Keep it short and to the point. 0.96. What is the ratio of the Employment to population ratio(%) of Malawi in 1996 to that in 1997?
Make the answer very short. 1. What is the ratio of the Employment to population ratio(%) of Lower middle income in 1996 to that in 1998?
Keep it short and to the point. 1.05. What is the ratio of the Employment to population ratio(%) in Albania in 1996 to that in 1998?
Your answer should be compact. 1.01. What is the ratio of the Employment to population ratio(%) of Angola in 1996 to that in 1998?
Your response must be concise. 1.03. What is the ratio of the Employment to population ratio(%) in Malawi in 1996 to that in 1998?
Offer a very short reply. 1.01. What is the ratio of the Employment to population ratio(%) in Lower middle income in 1996 to that in 1999?
Make the answer very short. 1.04. What is the ratio of the Employment to population ratio(%) of Albania in 1996 to that in 1999?
Your answer should be compact. 1.03. What is the ratio of the Employment to population ratio(%) in Angola in 1996 to that in 1999?
Your answer should be very brief. 1.03. What is the ratio of the Employment to population ratio(%) of Malawi in 1996 to that in 1999?
Your response must be concise. 0.98. What is the ratio of the Employment to population ratio(%) of Lower middle income in 1996 to that in 2000?
Provide a succinct answer. 1.07. What is the ratio of the Employment to population ratio(%) in Albania in 1996 to that in 2000?
Provide a succinct answer. 0.95. What is the ratio of the Employment to population ratio(%) of Angola in 1996 to that in 2000?
Your answer should be compact. 1.03. What is the ratio of the Employment to population ratio(%) in Malawi in 1996 to that in 2000?
Offer a very short reply. 0.95. What is the ratio of the Employment to population ratio(%) of Lower middle income in 1997 to that in 1998?
Provide a succinct answer. 1.03. What is the ratio of the Employment to population ratio(%) of Albania in 1997 to that in 1998?
Provide a short and direct response. 1.05. What is the ratio of the Employment to population ratio(%) in Angola in 1997 to that in 1998?
Your answer should be very brief. 1.01. What is the ratio of the Employment to population ratio(%) in Lower middle income in 1997 to that in 1999?
Give a very brief answer. 1.02. What is the ratio of the Employment to population ratio(%) in Albania in 1997 to that in 1999?
Ensure brevity in your answer.  1.07. What is the ratio of the Employment to population ratio(%) of Angola in 1997 to that in 1999?
Your answer should be compact. 1.01. What is the ratio of the Employment to population ratio(%) in Malawi in 1997 to that in 1999?
Your answer should be very brief. 0.97. What is the ratio of the Employment to population ratio(%) of Lower middle income in 1997 to that in 2000?
Give a very brief answer. 1.04. What is the ratio of the Employment to population ratio(%) of Albania in 1997 to that in 2000?
Offer a very short reply. 0.99. What is the ratio of the Employment to population ratio(%) in Angola in 1997 to that in 2000?
Give a very brief answer. 1.01. What is the ratio of the Employment to population ratio(%) in Malawi in 1997 to that in 2000?
Your answer should be very brief. 0.95. What is the ratio of the Employment to population ratio(%) of Albania in 1998 to that in 1999?
Your answer should be compact. 1.02. What is the ratio of the Employment to population ratio(%) in Angola in 1998 to that in 1999?
Offer a terse response. 1. What is the ratio of the Employment to population ratio(%) of Malawi in 1998 to that in 1999?
Your response must be concise. 0.97. What is the ratio of the Employment to population ratio(%) of Lower middle income in 1998 to that in 2000?
Your answer should be very brief. 1.02. What is the ratio of the Employment to population ratio(%) in Albania in 1998 to that in 2000?
Ensure brevity in your answer.  0.94. What is the ratio of the Employment to population ratio(%) of Angola in 1998 to that in 2000?
Your response must be concise. 1. What is the ratio of the Employment to population ratio(%) of Malawi in 1998 to that in 2000?
Offer a very short reply. 0.94. What is the ratio of the Employment to population ratio(%) of Lower middle income in 1999 to that in 2000?
Provide a short and direct response. 1.02. What is the ratio of the Employment to population ratio(%) in Albania in 1999 to that in 2000?
Ensure brevity in your answer.  0.92. What is the ratio of the Employment to population ratio(%) of Angola in 1999 to that in 2000?
Provide a short and direct response. 1. What is the ratio of the Employment to population ratio(%) in Malawi in 1999 to that in 2000?
Your response must be concise. 0.97. What is the difference between the highest and the second highest Employment to population ratio(%) in Lower middle income?
Your answer should be very brief. 0.26. What is the difference between the highest and the second highest Employment to population ratio(%) in Malawi?
Offer a very short reply. 1.4. What is the difference between the highest and the lowest Employment to population ratio(%) of Lower middle income?
Keep it short and to the point. 2.47. What is the difference between the highest and the lowest Employment to population ratio(%) in Malawi?
Give a very brief answer. 3.4. 